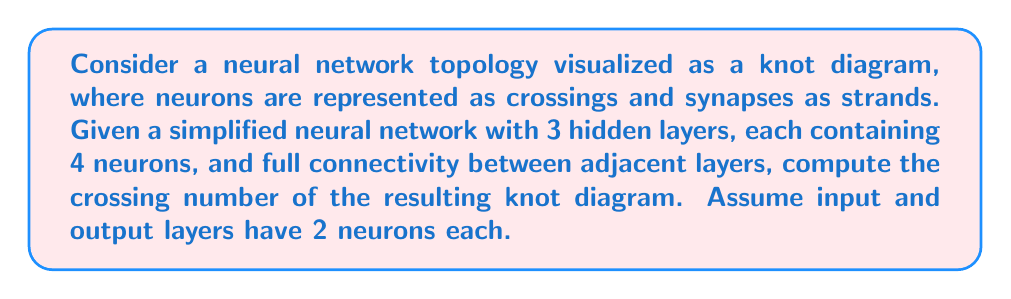Can you answer this question? To solve this problem, we'll follow these steps:

1) First, let's visualize the neural network structure:
   - Input layer: 2 neurons
   - Hidden layer 1: 4 neurons
   - Hidden layer 2: 4 neurons
   - Hidden layer 3: 4 neurons
   - Output layer: 2 neurons

2) In knot theory, the crossing number is the minimum number of crossings in any diagram of the knot. In our case, each neuron represents a crossing.

3) Count the neurons (crossings) in each layer:
   - Input layer: 2
   - Hidden layers: 4 + 4 + 4 = 12
   - Output layer: 2

4) Sum up all crossings:
   $$ 2 + 12 + 2 = 16 $$

5) However, the question asks for full connectivity between adjacent layers. This means each neuron in one layer connects to every neuron in the next layer. These connections create additional crossings.

6) Calculate additional crossings:
   - Between input and first hidden layer: $2 \times 4 = 8$
   - Between hidden layers: $4 \times 4 = 16$ (twice, as there are two transitions)
   - Between last hidden layer and output: $4 \times 2 = 8$

7) Sum up additional crossings:
   $$ 8 + 16 + 16 + 8 = 48 $$

8) Total crossing number:
   $$ 16 \text{ (neurons)} + 48 \text{ (connections)} = 64 $$

Therefore, the crossing number of this neural network topology visualized as a knot diagram is 64.
Answer: 64 